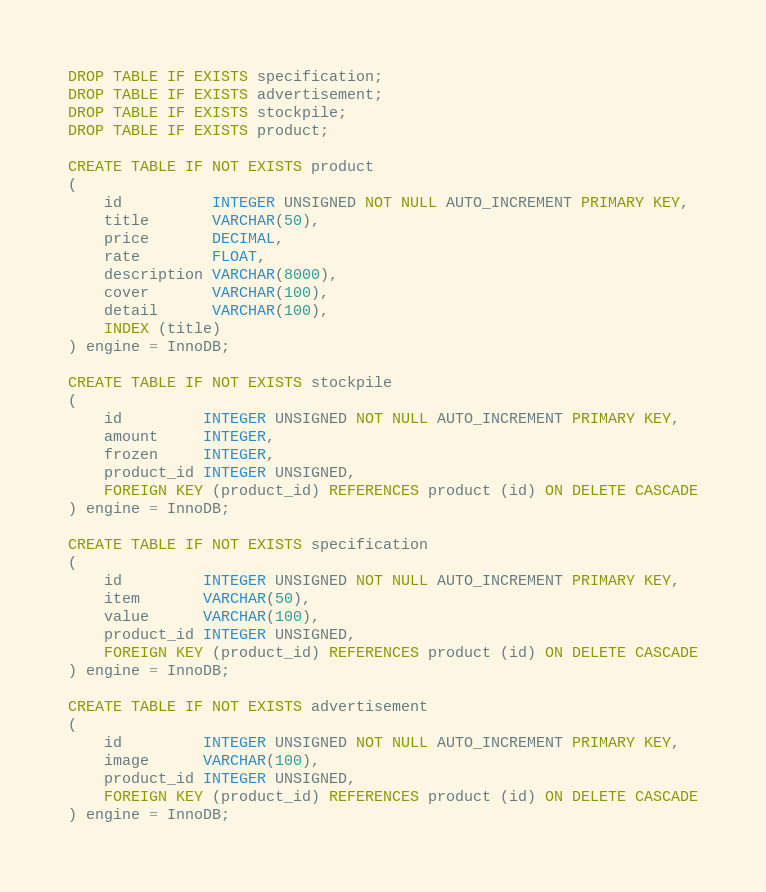Convert code to text. <code><loc_0><loc_0><loc_500><loc_500><_SQL_>DROP TABLE IF EXISTS specification;
DROP TABLE IF EXISTS advertisement;
DROP TABLE IF EXISTS stockpile;
DROP TABLE IF EXISTS product;

CREATE TABLE IF NOT EXISTS product
(
    id          INTEGER UNSIGNED NOT NULL AUTO_INCREMENT PRIMARY KEY,
    title       VARCHAR(50),
    price       DECIMAL,
    rate        FLOAT,
    description VARCHAR(8000),
    cover       VARCHAR(100),
    detail      VARCHAR(100),
    INDEX (title)
) engine = InnoDB;

CREATE TABLE IF NOT EXISTS stockpile
(
    id         INTEGER UNSIGNED NOT NULL AUTO_INCREMENT PRIMARY KEY,
    amount     INTEGER,
    frozen     INTEGER,
    product_id INTEGER UNSIGNED,
    FOREIGN KEY (product_id) REFERENCES product (id) ON DELETE CASCADE
) engine = InnoDB;

CREATE TABLE IF NOT EXISTS specification
(
    id         INTEGER UNSIGNED NOT NULL AUTO_INCREMENT PRIMARY KEY,
    item       VARCHAR(50),
    value      VARCHAR(100),
    product_id INTEGER UNSIGNED,
    FOREIGN KEY (product_id) REFERENCES product (id) ON DELETE CASCADE
) engine = InnoDB;

CREATE TABLE IF NOT EXISTS advertisement
(
    id         INTEGER UNSIGNED NOT NULL AUTO_INCREMENT PRIMARY KEY,
    image      VARCHAR(100),
    product_id INTEGER UNSIGNED,
    FOREIGN KEY (product_id) REFERENCES product (id) ON DELETE CASCADE
) engine = InnoDB;
</code> 